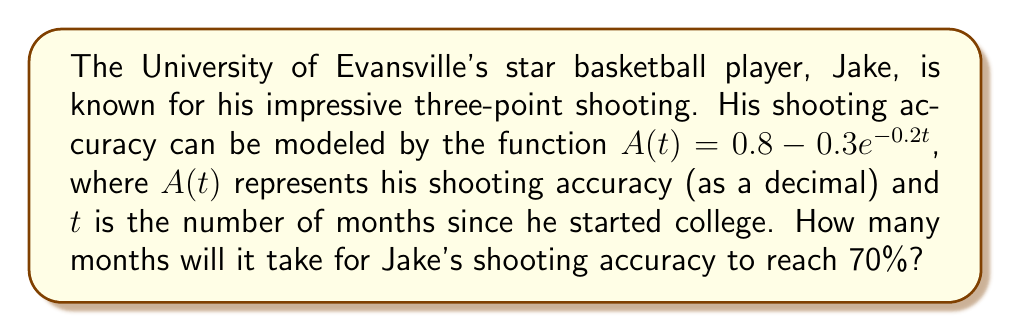Show me your answer to this math problem. Let's approach this step-by-step:

1) We need to find $t$ when $A(t) = 0.7$ (70% accuracy).

2) Set up the equation:
   $0.7 = 0.8 - 0.3e^{-0.2t}$

3) Subtract 0.8 from both sides:
   $-0.1 = -0.3e^{-0.2t}$

4) Divide both sides by -0.3:
   $\frac{1}{3} = e^{-0.2t}$

5) Take the natural log of both sides:
   $\ln(\frac{1}{3}) = -0.2t$

6) Divide both sides by -0.2:
   $\frac{\ln(\frac{1}{3})}{-0.2} = t$

7) Simplify:
   $t = \frac{-\ln(3)}{0.2} \approx 5.49$ months

8) Since we're dealing with months, we need to round up to the nearest whole month.
Answer: 6 months 